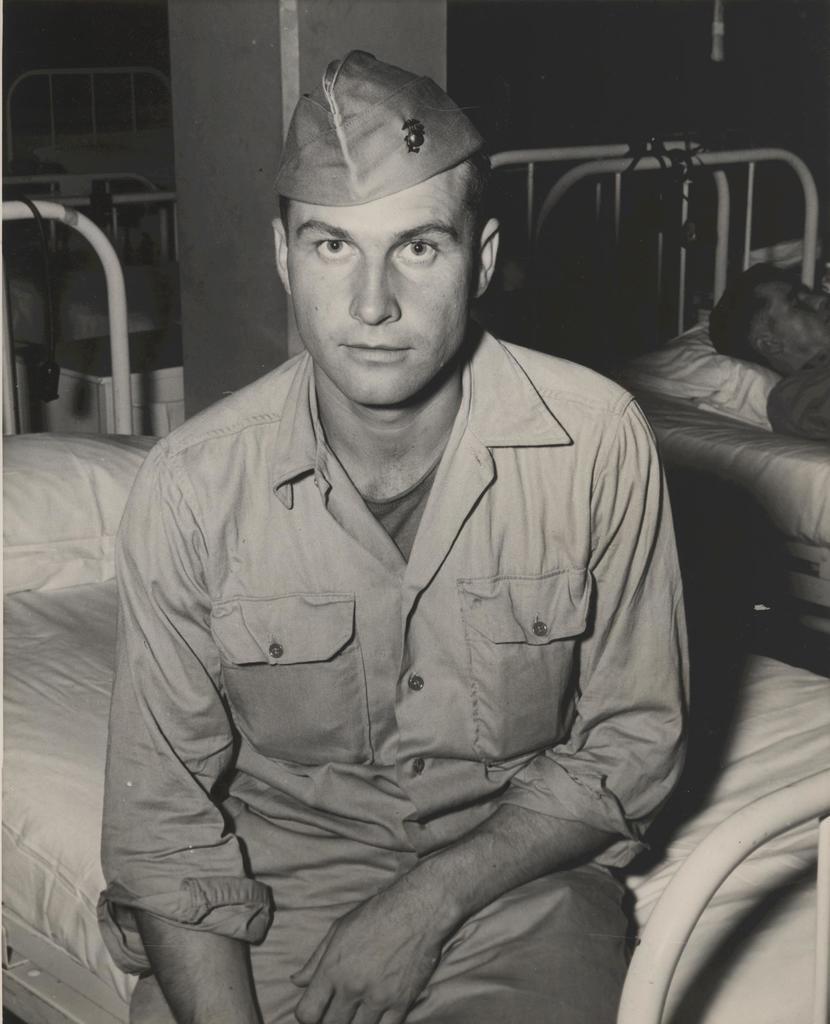Please provide a concise description of this image. This is the of the person wearing hat and sitting on the bed on which there is a pillow and beside there is another person laying on the bed. 